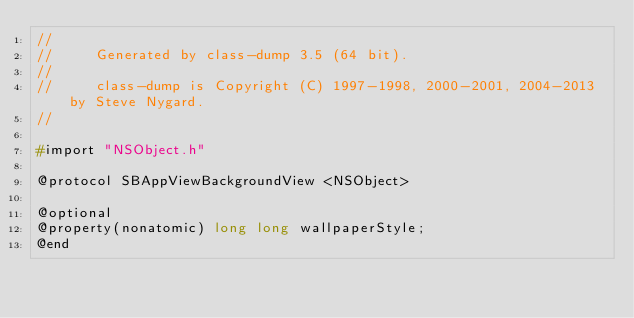Convert code to text. <code><loc_0><loc_0><loc_500><loc_500><_C_>//
//     Generated by class-dump 3.5 (64 bit).
//
//     class-dump is Copyright (C) 1997-1998, 2000-2001, 2004-2013 by Steve Nygard.
//

#import "NSObject.h"

@protocol SBAppViewBackgroundView <NSObject>

@optional
@property(nonatomic) long long wallpaperStyle;
@end

</code> 